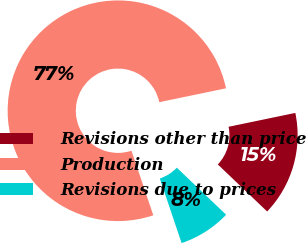<chart> <loc_0><loc_0><loc_500><loc_500><pie_chart><fcel>Revisions other than price<fcel>Production<fcel>Revisions due to prices<nl><fcel>15.38%<fcel>76.92%<fcel>7.69%<nl></chart> 